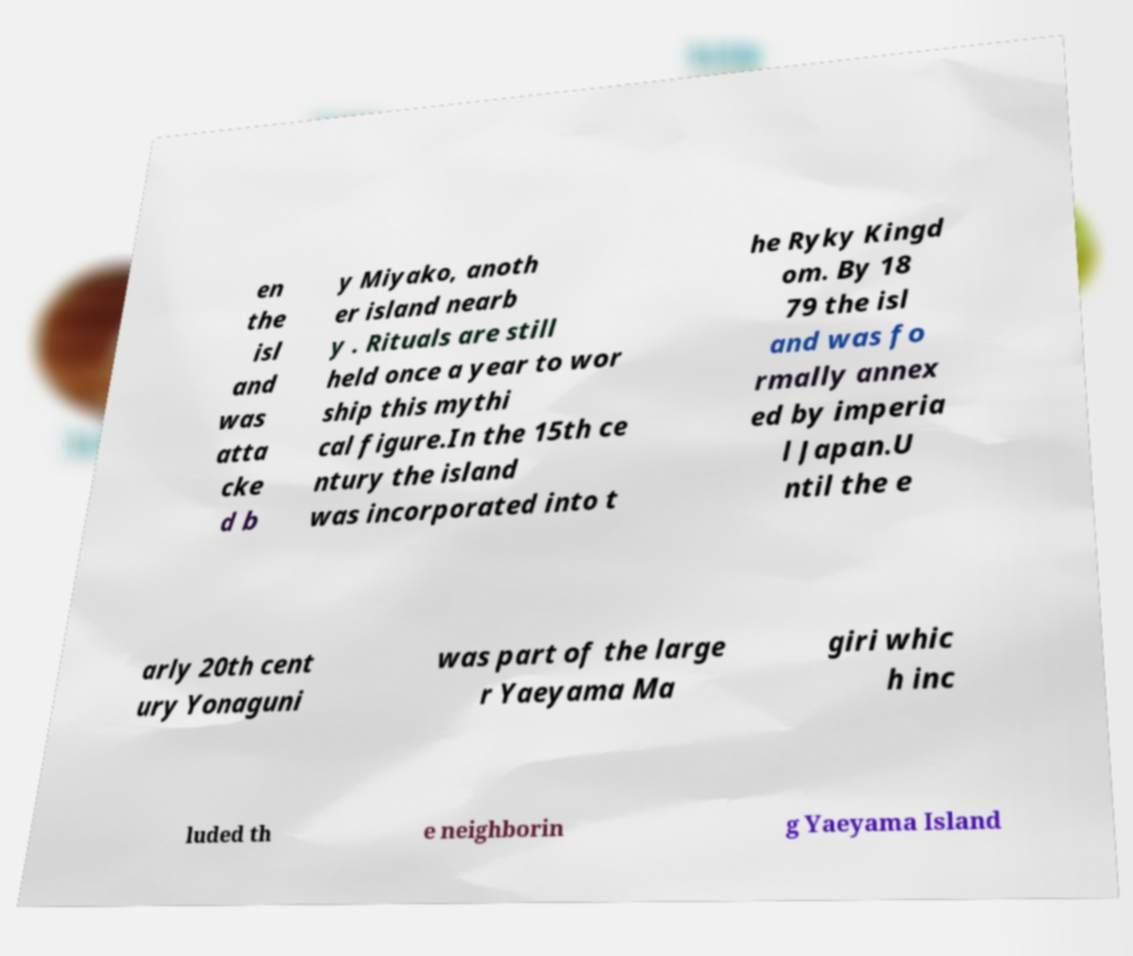There's text embedded in this image that I need extracted. Can you transcribe it verbatim? en the isl and was atta cke d b y Miyako, anoth er island nearb y . Rituals are still held once a year to wor ship this mythi cal figure.In the 15th ce ntury the island was incorporated into t he Ryky Kingd om. By 18 79 the isl and was fo rmally annex ed by imperia l Japan.U ntil the e arly 20th cent ury Yonaguni was part of the large r Yaeyama Ma giri whic h inc luded th e neighborin g Yaeyama Island 